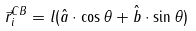Convert formula to latex. <formula><loc_0><loc_0><loc_500><loc_500>\vec { r } ^ { C B } _ { i } = l ( \hat { a } \cdot \cos { \theta } + \hat { b } \cdot \sin { \theta } )</formula> 